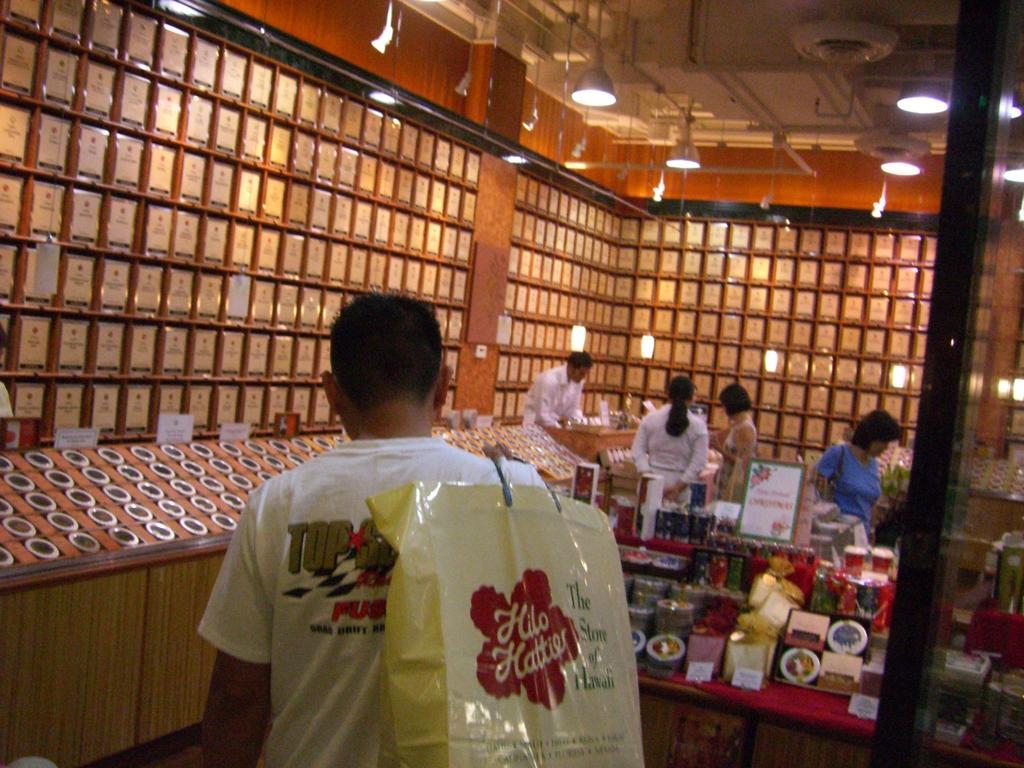Describe this image in one or two sentences. This picture describes about group of people, in the middle of the image we can see a man, he is holding a bag, in the background we can find lights and few things in the racks. 